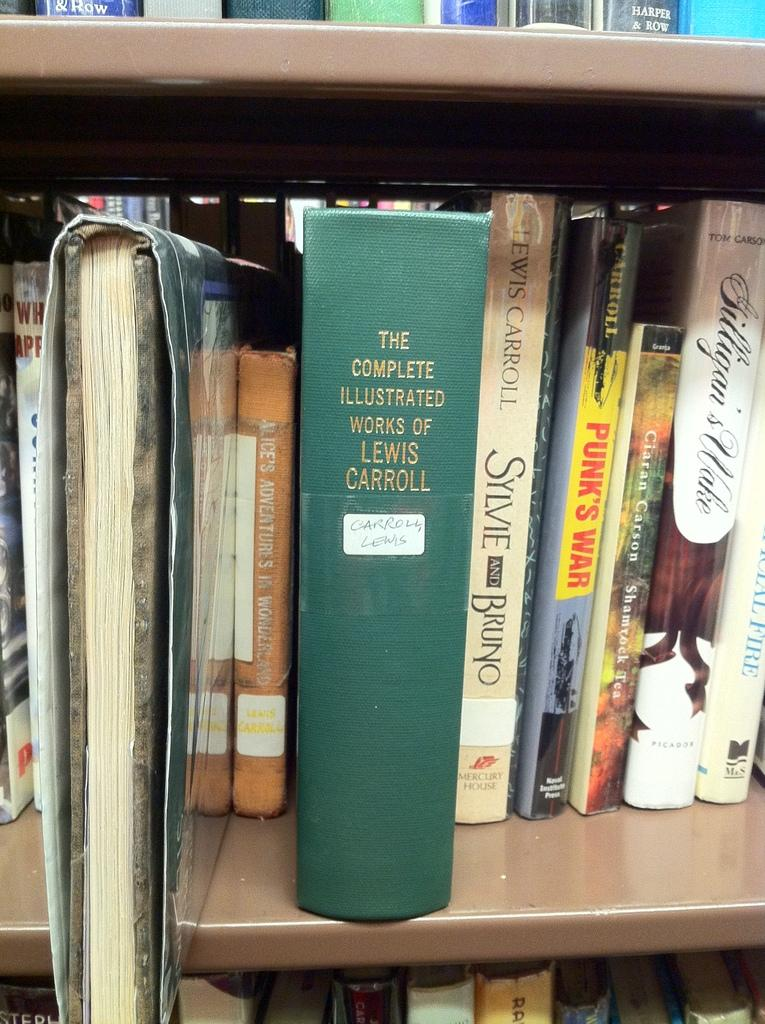Provide a one-sentence caption for the provided image. The bookshelf contains a thick green book containing the complete illustrated works of Lewis Carroll. 